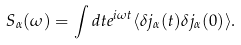Convert formula to latex. <formula><loc_0><loc_0><loc_500><loc_500>S _ { \alpha } ( \omega ) = \int d t e ^ { i \omega t } \langle \delta j _ { \alpha } ( t ) \delta j _ { \alpha } ( 0 ) \rangle .</formula> 